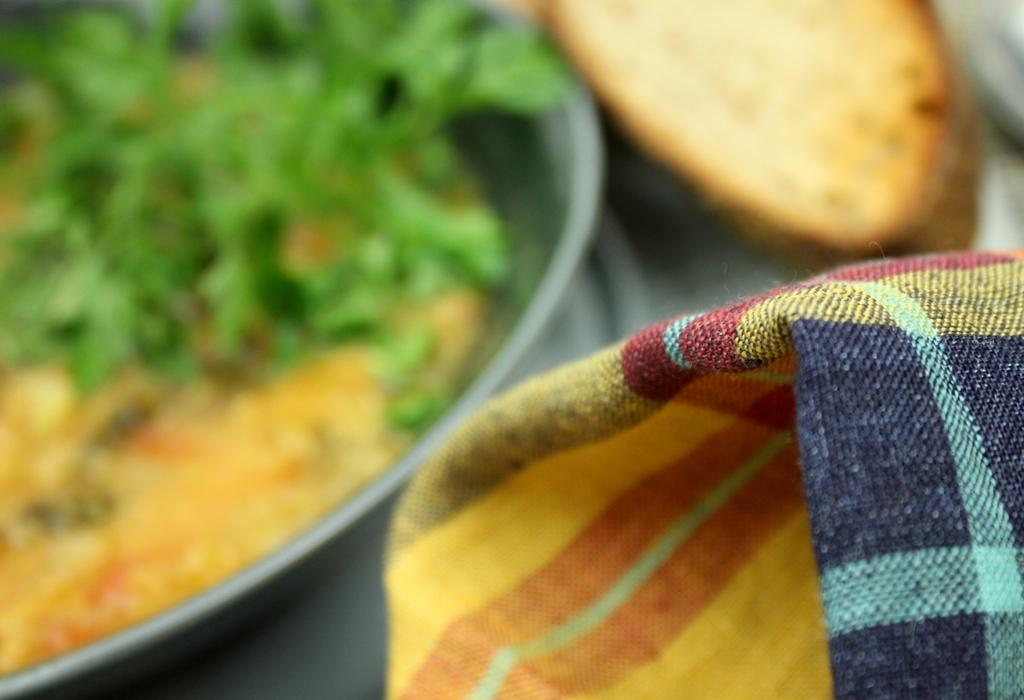What can be seen in the image that is made of fabric? There is a cloth in the image. How would you describe the appearance of the background in the image? The background of the image is blurry. What type of dishware is present in the image? There is a plate with a food item in the image. Can you describe the unspecified object in the image? Unfortunately, the facts provided do not give enough information to describe the unspecified object in the image. What type of amusement can be seen in the image? There is no amusement present in the image. What is the yoke used for in the image? There is no yoke present in the image. 